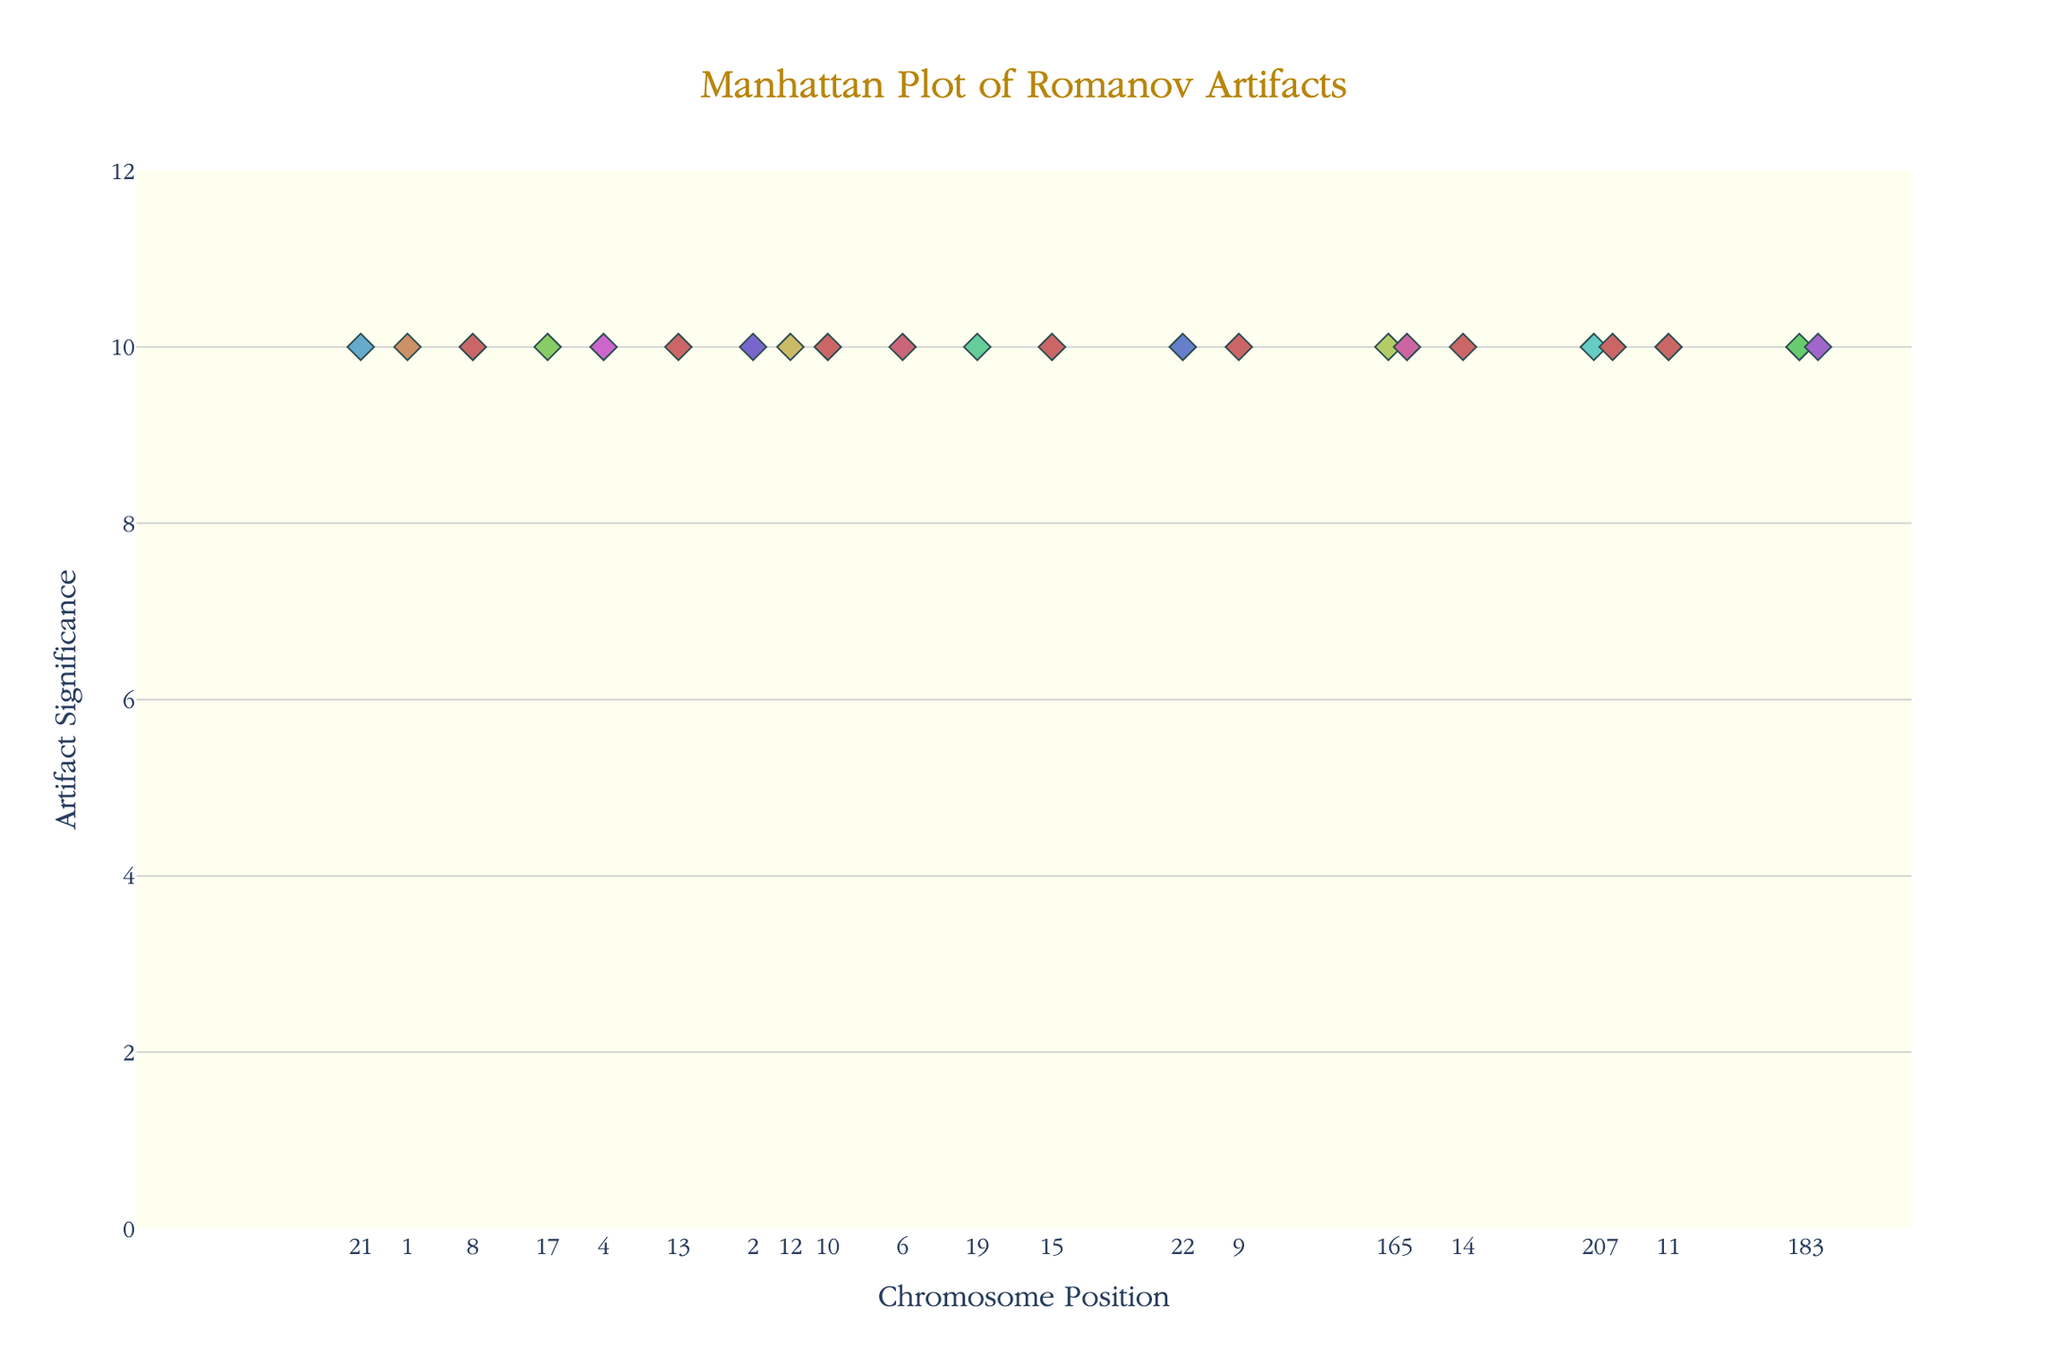what is the title of the plot? The title of the plot is prominently displayed at the top and reads "Manhattan Plot of Romanov Artifacts".
Answer: Manhattan Plot of Romanov Artifacts What is the color of the markers for Chromosome 1? The markers for Chromosome 1 can be identified by their color, which is consistent throughout all points marked for Chromosome 1. According to the color map, Chromosome 1 is colored in a hue of the HSL spectrum—specifically, the shade used is a variant of 25 degrees hue, 50% saturation, and 60% lightness. In general terms, this would appear like an orange shade.
Answer: Orange shade How many chromosomes are included in this plot? Each unique chromosome is indicated by differently colored markers and labeled on the x-axis. There are 22 different chromosomes, labeled 1 through 22.
Answer: 22 Which chromosome position shows Tsarina Alexandra's Tiara? By looking at the markers and their associated text that appears when hovered over or referenced in the legend, we can find that Tsarina Alexandra's Tiara occurs at Chromosome 13 at the position of approximately 68,000,000.
Answer: Chromosome 13 at 68,000,000 What is the range of the y-axis? The y-axis range can be determined by looking at its title and the numerical labels running along it. The y-axis, labeled "Artifact Significance," ranges from 0 to 12.
Answer: 0 to 12 Which artifact corresponds to the highest position on the plot? To identify the artifact, examine the markers and hover text at the highest y-value. The highest y-value across all chromosomes is consistent (as per placeholder). The artifact at the highest y-value is the Romanov Family Photo Album, located on Chromosome 11 at position 90,000,000.
Answer: Romanov Family Photo Album How does the significance of Peter the Great's Scepter compare to Grand Duchess Tatiana's Nursing Medal? To compare these two artifacts, locate their markers on the plot and compare their y-values. Both are plotted with the same placeholder significance value of 10, located on Chromosome 20 at position 29,000,000 for the Scepter, and Chromosome 5 at position 89,000,000 for the Nursing Medal. Since both have the same y-value as per placeholder, they are equal in significance.
Answer: Equal significance Which chromosomes have their most significant artifacts located in the first 20,000,000 positions? Scan the plot for the positions and the corresponding chromosome labels for markers within the first 20,000,000 on the x-axis. Chromosome 1 with Nicholas II's Personal Diary at position 14,500,000 and Chromosome 8 with Tsarevich Alexei's Toy Sailor at position 12,000,000 meet this criterion.
Answer: Chromosome 1 and Chromosome 8 What is the average position of the artifacts on Chromosome 7? Chromosome 7 has only one artifact listed at position 78,000,000. As such, the average position of artifacts on this chromosome is simply that position.
Answer: 78,000,000 Which two chromosomes have artifacts named after Empress Alexandra Feodorovna? Check for artifacts associated with Empress Alexandra Feodorovna across all chromosomes. Alexandra appears with her Fabergé Egg on Chromosome 2 and her Prayer Book on Chromosome 9.
Answer: Chromosome 2 and Chromosome 9 